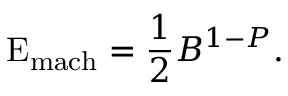<formula> <loc_0><loc_0><loc_500><loc_500>E _ { m a c h } = { \frac { 1 } { 2 } } B ^ { 1 - P } .</formula> 